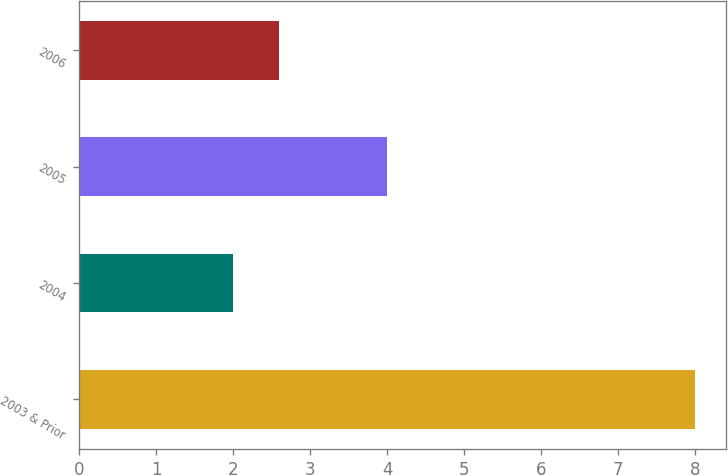Convert chart to OTSL. <chart><loc_0><loc_0><loc_500><loc_500><bar_chart><fcel>2003 & Prior<fcel>2004<fcel>2005<fcel>2006<nl><fcel>8<fcel>2<fcel>4<fcel>2.6<nl></chart> 